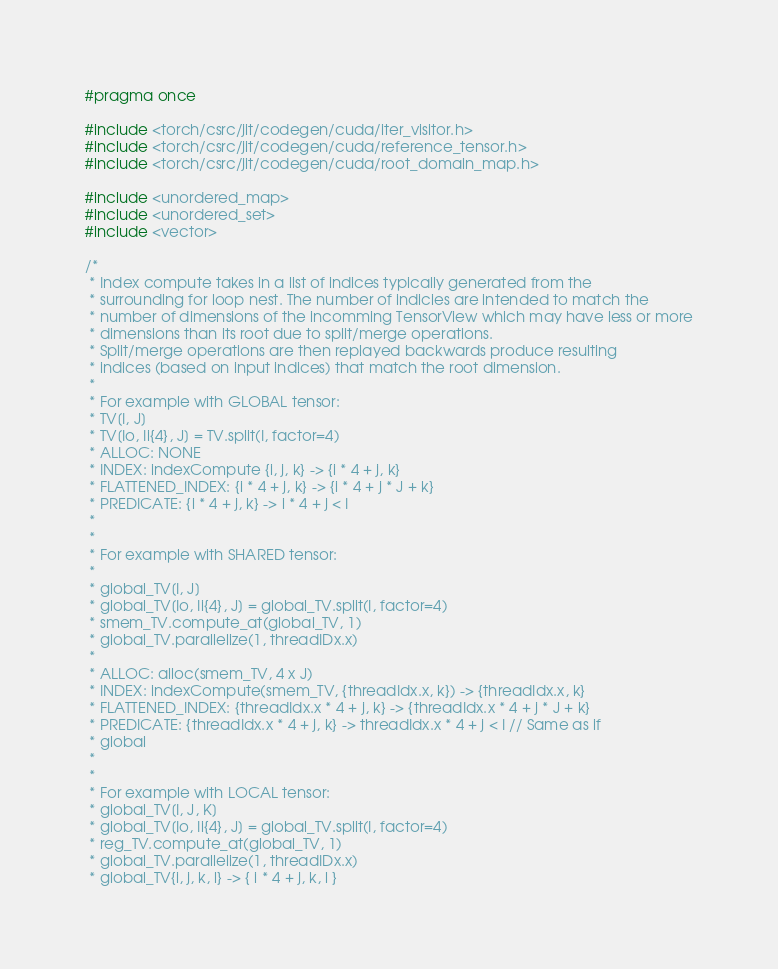<code> <loc_0><loc_0><loc_500><loc_500><_C_>#pragma once

#include <torch/csrc/jit/codegen/cuda/iter_visitor.h>
#include <torch/csrc/jit/codegen/cuda/reference_tensor.h>
#include <torch/csrc/jit/codegen/cuda/root_domain_map.h>

#include <unordered_map>
#include <unordered_set>
#include <vector>

/*
 * Index compute takes in a list of indices typically generated from the
 * surrounding for loop nest. The number of indicies are intended to match the
 * number of dimensions of the incomming TensorView which may have less or more
 * dimensions than its root due to split/merge operations.
 * Split/merge operations are then replayed backwards produce resulting
 * indices (based on input indices) that match the root dimension.
 *
 * For example with GLOBAL tensor:
 * TV[I, J]
 * TV[Io, Ii{4}, J] = TV.split(I, factor=4)
 * ALLOC: NONE
 * INDEX: indexCompute {i, j, k} -> {i * 4 + j, k}
 * FLATTENED_INDEX: {i * 4 + j, k} -> {i * 4 + j * J + k}
 * PREDICATE: {i * 4 + j, k} -> i * 4 + j < I
 *
 *
 * For example with SHARED tensor:
 *
 * global_TV[I, J]
 * global_TV[Io, Ii{4}, J] = global_TV.split(I, factor=4)
 * smem_TV.compute_at(global_TV, 1)
 * global_TV.parallelize(1, threadIDx.x)
 *
 * ALLOC: alloc(smem_TV, 4 x J)
 * INDEX: indexCompute(smem_TV, {threadIdx.x, k}) -> {threadIdx.x, k}
 * FLATTENED_INDEX: {threadIdx.x * 4 + j, k} -> {threadIdx.x * 4 + j * J + k}
 * PREDICATE: {threadIdx.x * 4 + j, k} -> threadIdx.x * 4 + j < I // Same as if
 * global
 *
 *
 * For example with LOCAL tensor:
 * global_TV[I, J, K]
 * global_TV[Io, Ii{4}, J] = global_TV.split(I, factor=4)
 * reg_TV.compute_at(global_TV, 1)
 * global_TV.parallelize(1, threadIDx.x)
 * global_TV{i, j, k, l} -> { i * 4 + j, k, l }</code> 